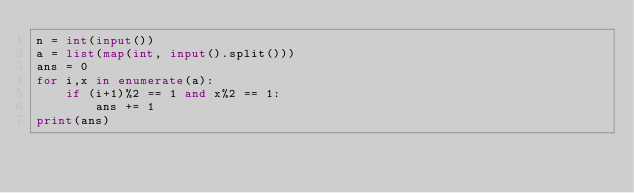Convert code to text. <code><loc_0><loc_0><loc_500><loc_500><_Python_>n = int(input())
a = list(map(int, input().split()))
ans = 0
for i,x in enumerate(a):
    if (i+1)%2 == 1 and x%2 == 1:
        ans += 1
print(ans)
</code> 